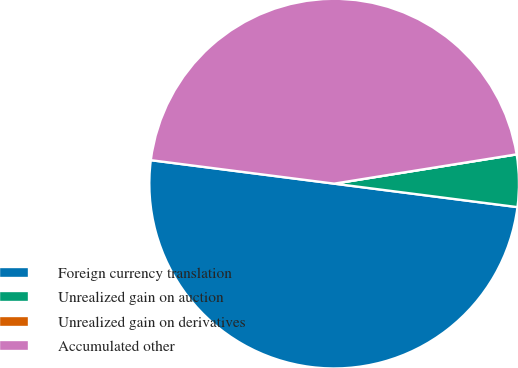Convert chart to OTSL. <chart><loc_0><loc_0><loc_500><loc_500><pie_chart><fcel>Foreign currency translation<fcel>Unrealized gain on auction<fcel>Unrealized gain on derivatives<fcel>Accumulated other<nl><fcel>50.0%<fcel>4.56%<fcel>0.0%<fcel>45.44%<nl></chart> 